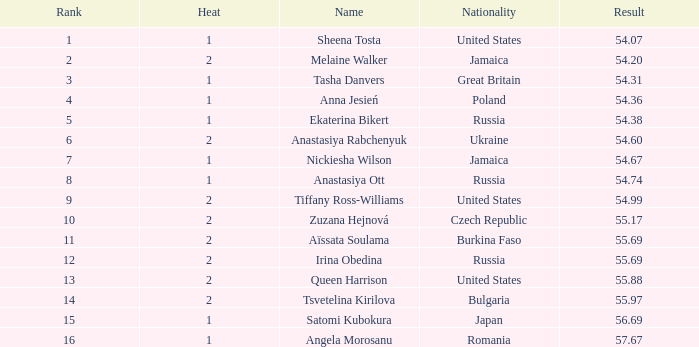97? None. 